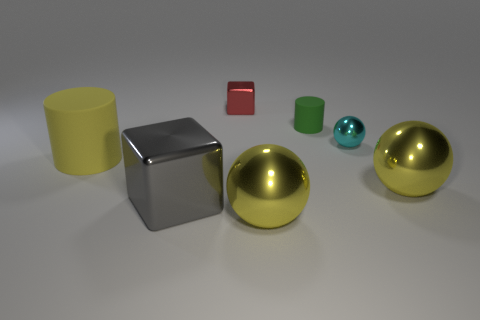What might the sizes of these objects tell us about their use or function? The sizes and shapes of the objects can offer clues to their potential uses. The smaller cylindrical and cube shapes might be handheld items or building blocks, commonly used for educational or design purposes. The spheres, due to their larger size, could serve as decorative elements or be part of a larger mechanical system if they were functional. Their uniformity and the context of their presentation seem to indicate they could also be part of a display for material or design reference. 